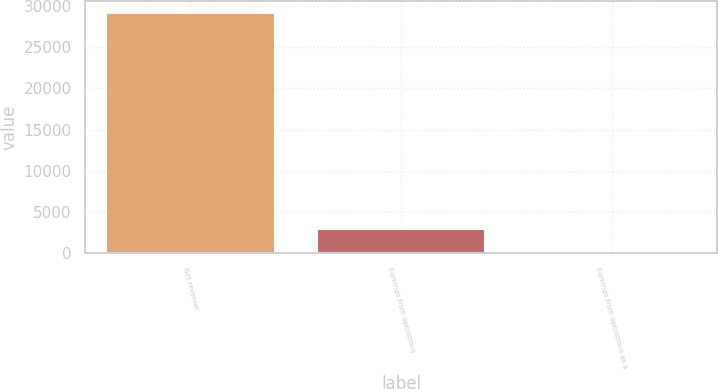Convert chart. <chart><loc_0><loc_0><loc_500><loc_500><bar_chart><fcel>Net revenue<fcel>Earnings from operations<fcel>Earnings from operations as a<nl><fcel>29166<fcel>2920.11<fcel>3.9<nl></chart> 